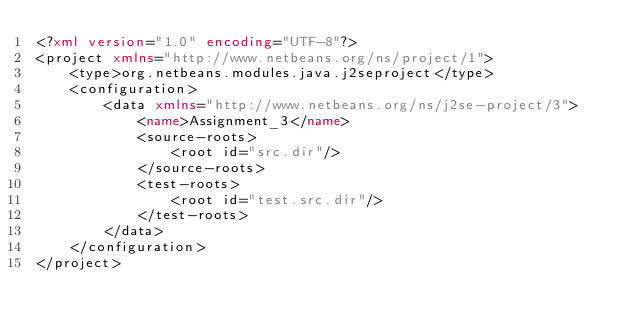Convert code to text. <code><loc_0><loc_0><loc_500><loc_500><_XML_><?xml version="1.0" encoding="UTF-8"?>
<project xmlns="http://www.netbeans.org/ns/project/1">
    <type>org.netbeans.modules.java.j2seproject</type>
    <configuration>
        <data xmlns="http://www.netbeans.org/ns/j2se-project/3">
            <name>Assignment_3</name>
            <source-roots>
                <root id="src.dir"/>
            </source-roots>
            <test-roots>
                <root id="test.src.dir"/>
            </test-roots>
        </data>
    </configuration>
</project>
</code> 